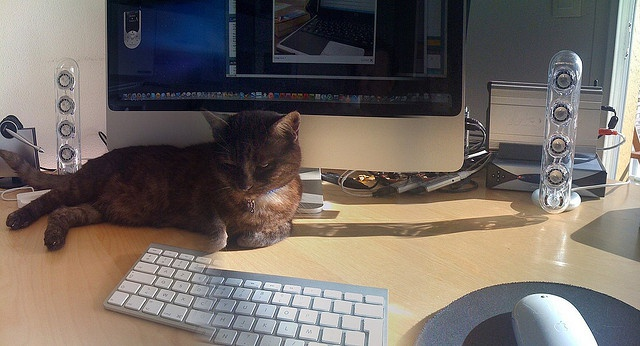Describe the objects in this image and their specific colors. I can see tv in lightgray, black, navy, gray, and darkblue tones, cat in lightgray, black, maroon, brown, and gray tones, keyboard in lightgray, darkgray, gray, and tan tones, and mouse in lightgray, white, gray, darkgray, and lightblue tones in this image. 